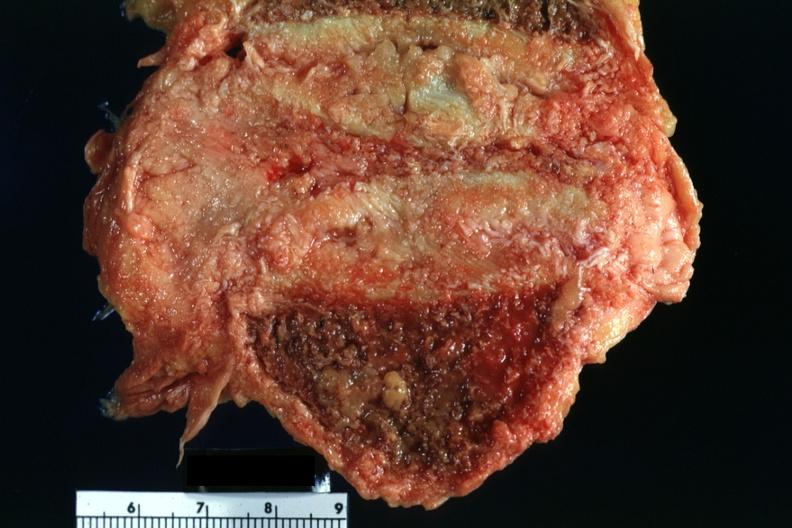how does this image show close-up of collapsed vertebral body?
Answer the question using a single word or phrase. With tumor rather easily seen 